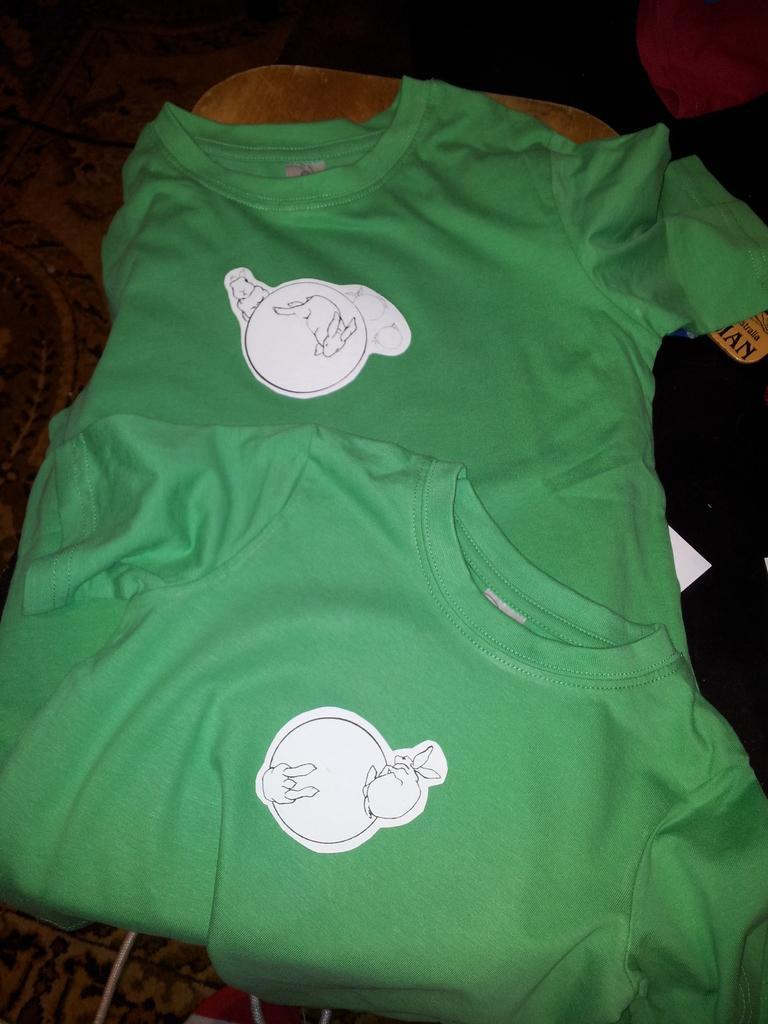Could you give a brief overview of what you see in this image? Here, we can see two green color t-shirts. 